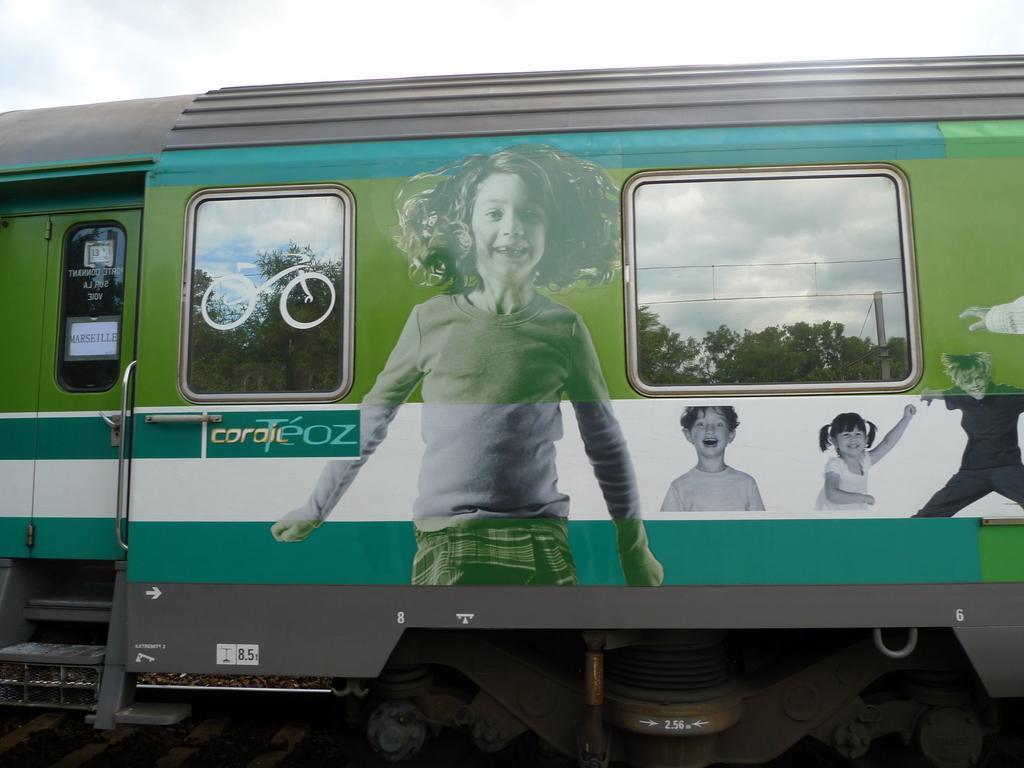Could you give a brief overview of what you see in this image? In this image we can see green color train. The sky is covered with clouds. 